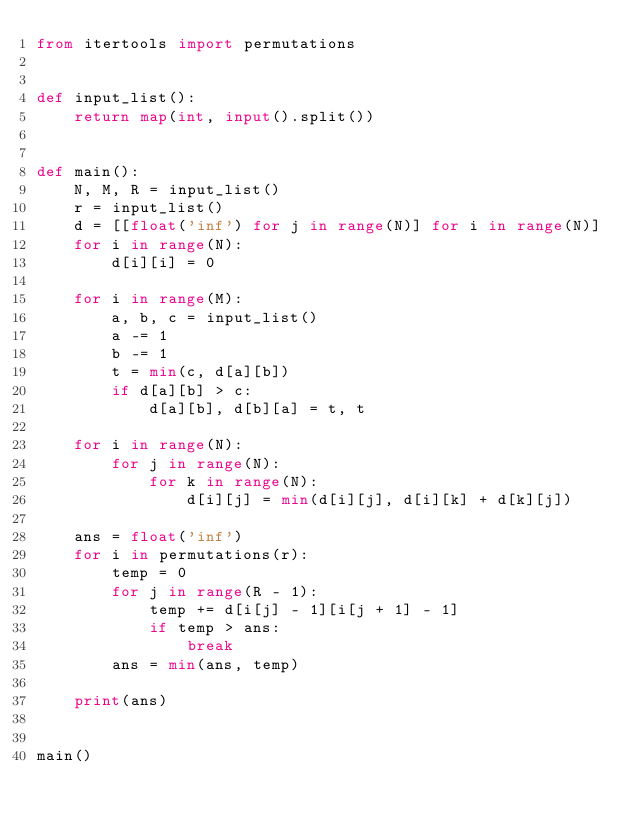Convert code to text. <code><loc_0><loc_0><loc_500><loc_500><_Python_>from itertools import permutations


def input_list():
    return map(int, input().split())


def main():
    N, M, R = input_list()
    r = input_list()
    d = [[float('inf') for j in range(N)] for i in range(N)]
    for i in range(N):
        d[i][i] = 0

    for i in range(M):
        a, b, c = input_list()
        a -= 1
        b -= 1
        t = min(c, d[a][b])
        if d[a][b] > c:
            d[a][b], d[b][a] = t, t

    for i in range(N):
        for j in range(N):
            for k in range(N):
                d[i][j] = min(d[i][j], d[i][k] + d[k][j])

    ans = float('inf')
    for i in permutations(r):
        temp = 0
        for j in range(R - 1):
            temp += d[i[j] - 1][i[j + 1] - 1]
            if temp > ans:
                break
        ans = min(ans, temp)

    print(ans)


main()
</code> 